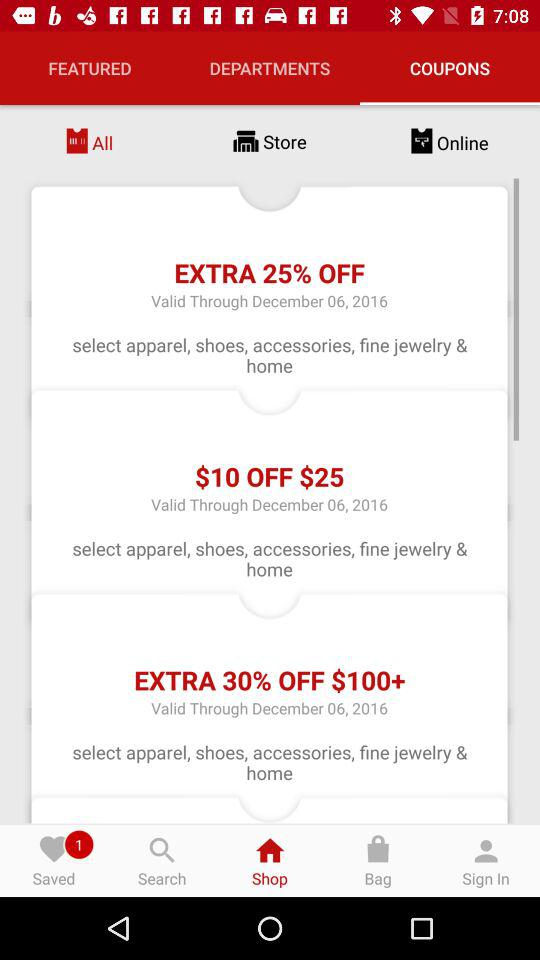How many coupons are valid through December 06, 2016?
Answer the question using a single word or phrase. 3 